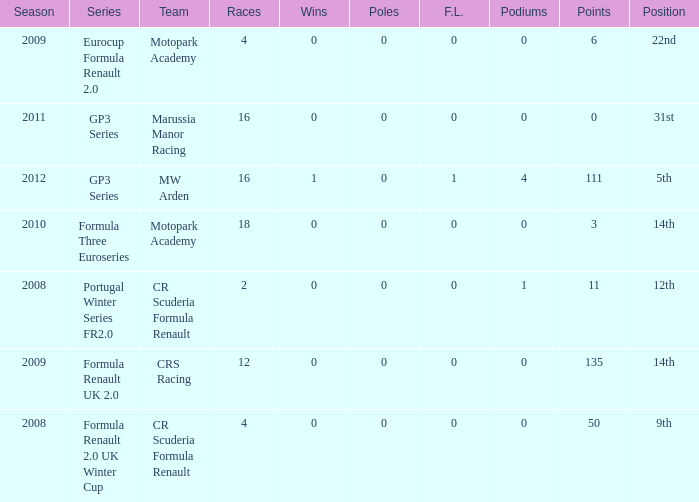What are the most poles listed? 0.0. 